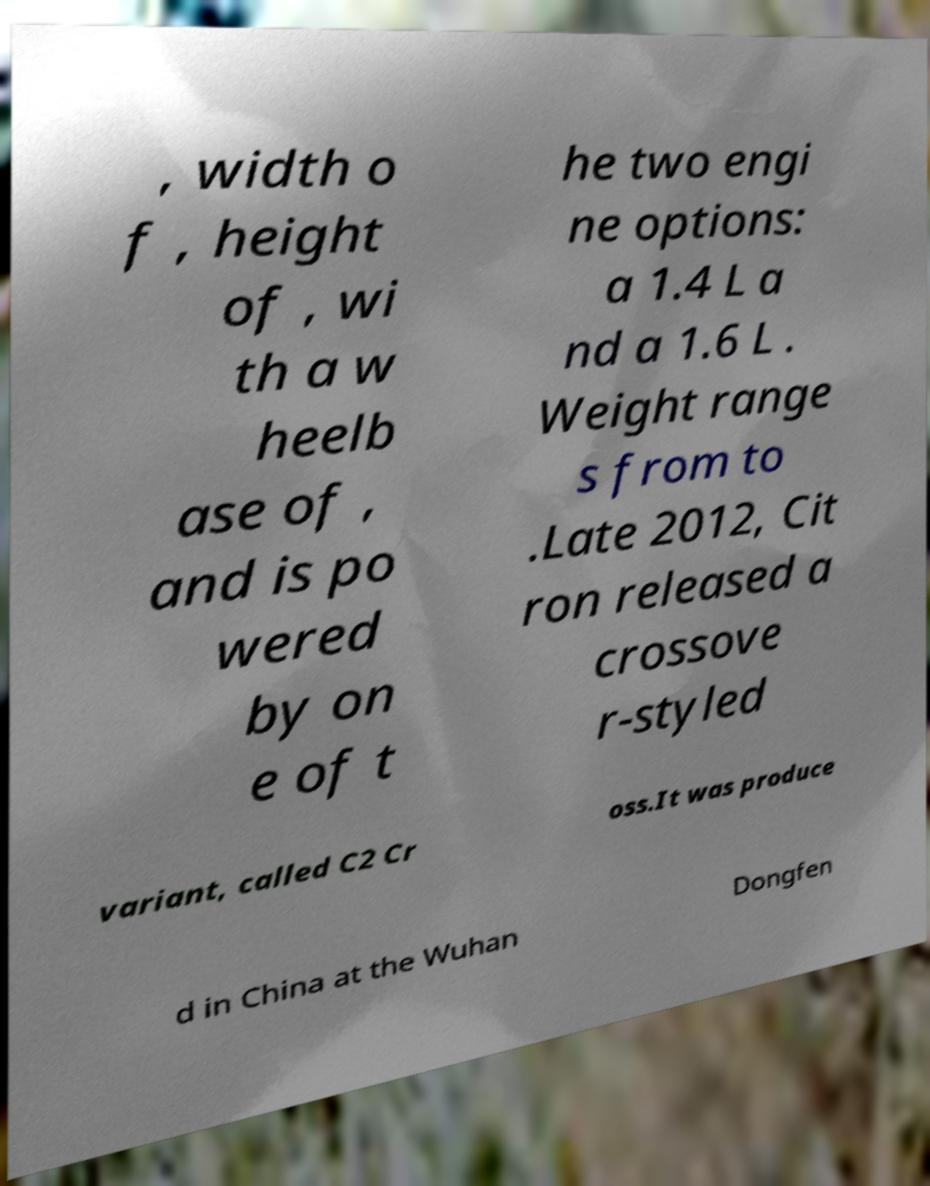For documentation purposes, I need the text within this image transcribed. Could you provide that? , width o f , height of , wi th a w heelb ase of , and is po wered by on e of t he two engi ne options: a 1.4 L a nd a 1.6 L . Weight range s from to .Late 2012, Cit ron released a crossove r-styled variant, called C2 Cr oss.It was produce d in China at the Wuhan Dongfen 